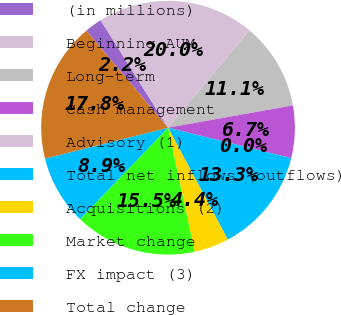<chart> <loc_0><loc_0><loc_500><loc_500><pie_chart><fcel>(in millions)<fcel>Beginning AUM<fcel>Long-term<fcel>Cash management<fcel>Advisory (1)<fcel>Total net inflows (outflows)<fcel>Acquisitions (2)<fcel>Market change<fcel>FX impact (3)<fcel>Total change<nl><fcel>2.23%<fcel>20.0%<fcel>11.11%<fcel>6.67%<fcel>0.0%<fcel>13.33%<fcel>4.45%<fcel>15.55%<fcel>8.89%<fcel>17.77%<nl></chart> 